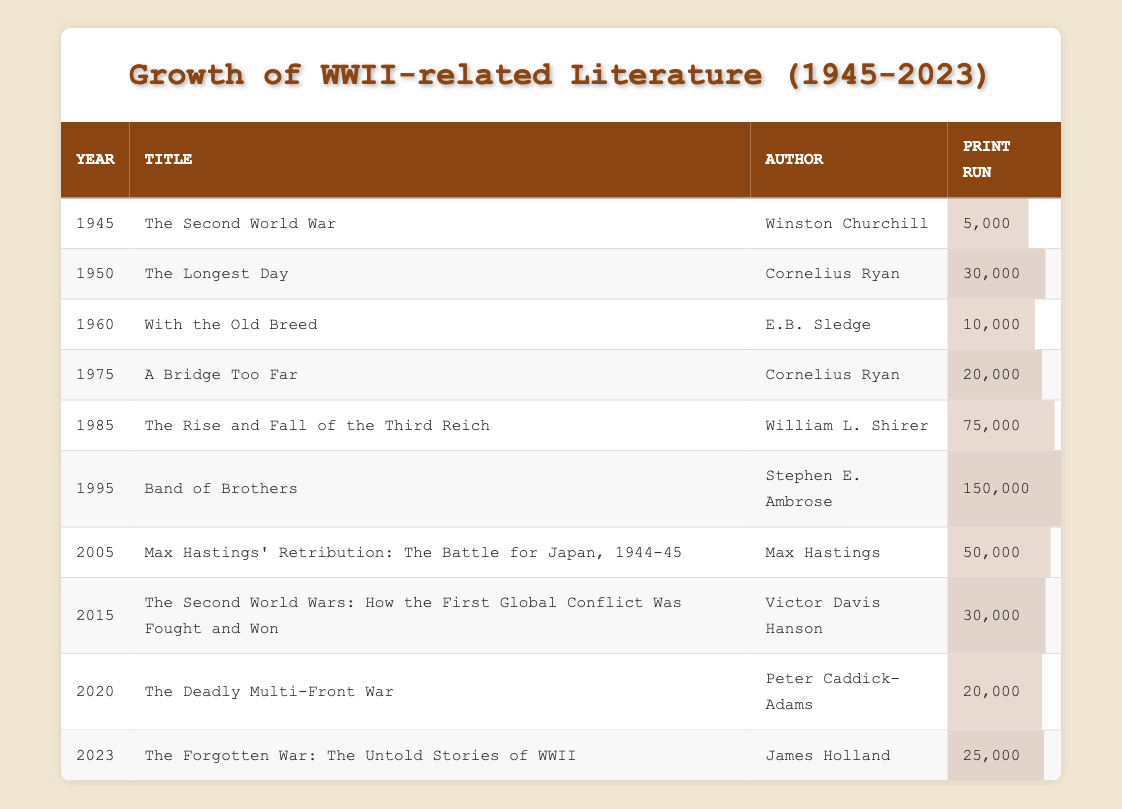What was the print run of "The Rise and Fall of the Third Reich"? According to the table, the print run of "The Rise and Fall of the Third Reich" by William L. Shirer in 1985 is listed as 75,000.
Answer: 75,000 How many books had a print run of over 50,000? From the table, I'll identify the books with print runs over 50,000. They are: "The Rise and Fall of the Third Reich" (75,000), "Band of Brothers" (150,000). Therefore, there are 2 books with a print run over 50,000.
Answer: 2 Was "Band of Brothers" published before 2000? The table indicates that "Band of Brothers" was published in 1995, which is before the year 2000.
Answer: Yes What is the year with the highest print run and what is that number? Looking through the table, "Band of Brothers" published in 1995 has the highest print run of 150,000. Thus, the year with the highest print run is 1995 with the print run of 150,000.
Answer: 1995, 150,000 What is the average print run for the years 1975 to 2023? First, I need to gather the print runs from the relevant years: 20,000 (1975), 75,000 (1985), 150,000 (1995), 50,000 (2005), 30,000 (2015), 20,000 (2020), 25,000 (2023). The total is (20,000 + 75,000 + 150,000 + 50,000 + 30,000 + 20,000 + 25,000) = 370,000 over 7 years. Thus, the average is 370,000 / 7 = 52,857.14, rounded can be 52,857.
Answer: 52,857 What was the difference in print runs between the years 1950 and 1985? According to the table, the print run for 1950 (30,000) and for 1985 (75,000) are given. The difference is calculated as 75,000 - 30,000 = 45,000.
Answer: 45,000 Which author had the highest total print run for their works, and what was that total? I need to sum the print runs for each author's contributions. For Cornelius Ryan: 30,000 + 20,000 = 50,000; Winston Churchill: 5,000; E.B. Sledge: 10,000; William L. Shirer: 75,000; Stephen E. Ambrose: 150,000; Max Hastings: 50,000; Victor Davis Hanson: 30,000; Peter Caddick-Adams: 20,000; James Holland: 25,000. The highest total is 150,000 by Stephen E. Ambrose.
Answer: Stephen E. Ambrose, 150,000 